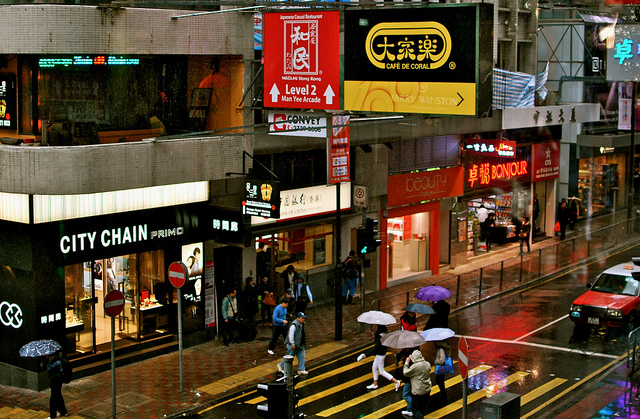Extract all visible text content from this image. Level 2 CITY CHAIN PRIMO CONVEY beauty BONJOUR CORAAL 